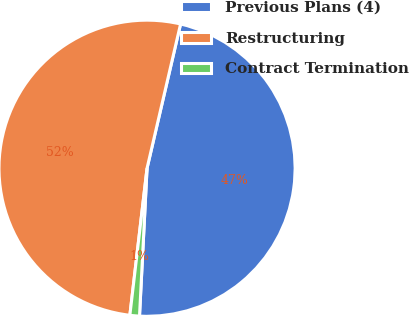Convert chart. <chart><loc_0><loc_0><loc_500><loc_500><pie_chart><fcel>Previous Plans (4)<fcel>Restructuring<fcel>Contract Termination<nl><fcel>47.18%<fcel>51.79%<fcel>1.04%<nl></chart> 